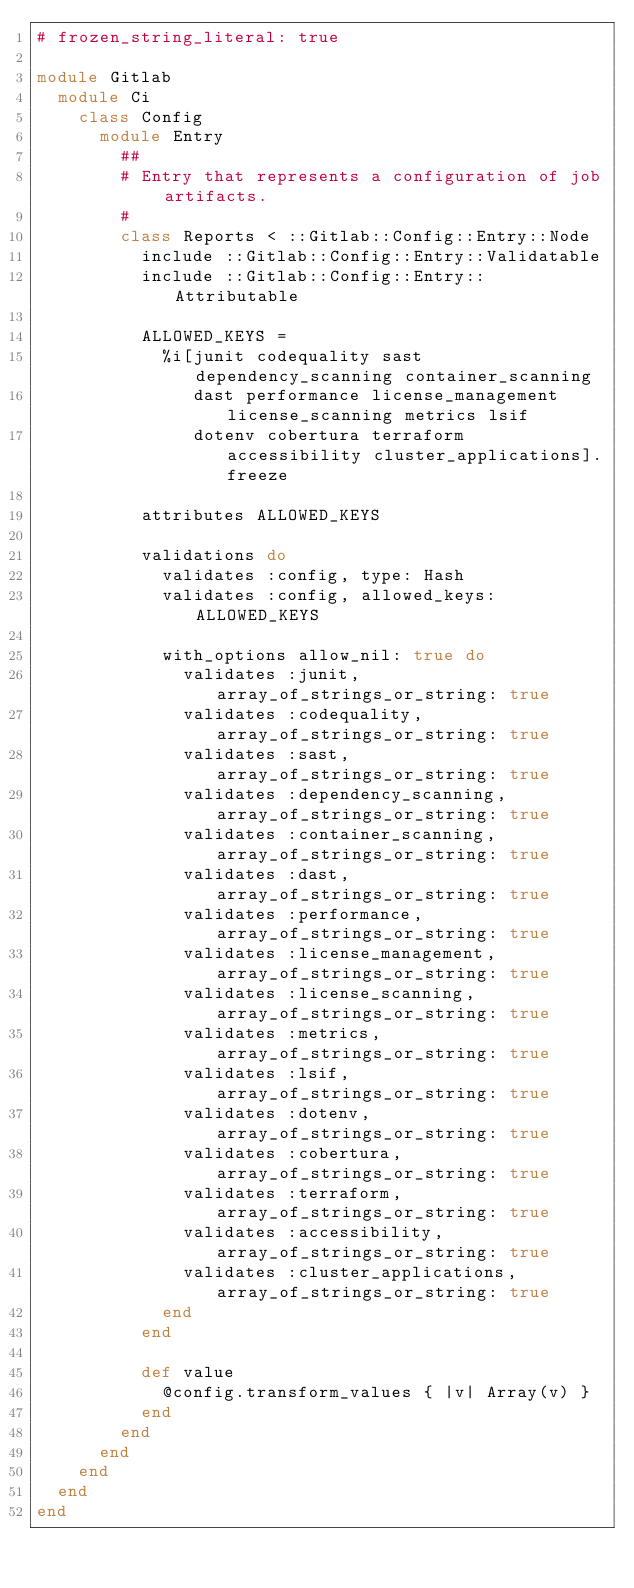<code> <loc_0><loc_0><loc_500><loc_500><_Ruby_># frozen_string_literal: true

module Gitlab
  module Ci
    class Config
      module Entry
        ##
        # Entry that represents a configuration of job artifacts.
        #
        class Reports < ::Gitlab::Config::Entry::Node
          include ::Gitlab::Config::Entry::Validatable
          include ::Gitlab::Config::Entry::Attributable

          ALLOWED_KEYS =
            %i[junit codequality sast dependency_scanning container_scanning
               dast performance license_management license_scanning metrics lsif
               dotenv cobertura terraform accessibility cluster_applications].freeze

          attributes ALLOWED_KEYS

          validations do
            validates :config, type: Hash
            validates :config, allowed_keys: ALLOWED_KEYS

            with_options allow_nil: true do
              validates :junit, array_of_strings_or_string: true
              validates :codequality, array_of_strings_or_string: true
              validates :sast, array_of_strings_or_string: true
              validates :dependency_scanning, array_of_strings_or_string: true
              validates :container_scanning, array_of_strings_or_string: true
              validates :dast, array_of_strings_or_string: true
              validates :performance, array_of_strings_or_string: true
              validates :license_management, array_of_strings_or_string: true
              validates :license_scanning, array_of_strings_or_string: true
              validates :metrics, array_of_strings_or_string: true
              validates :lsif, array_of_strings_or_string: true
              validates :dotenv, array_of_strings_or_string: true
              validates :cobertura, array_of_strings_or_string: true
              validates :terraform, array_of_strings_or_string: true
              validates :accessibility, array_of_strings_or_string: true
              validates :cluster_applications, array_of_strings_or_string: true
            end
          end

          def value
            @config.transform_values { |v| Array(v) }
          end
        end
      end
    end
  end
end
</code> 